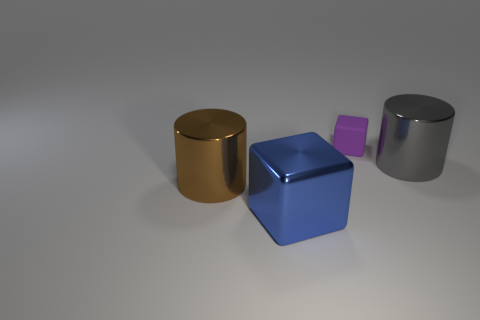Are there any other things that are made of the same material as the purple cube?
Offer a very short reply. No. There is a brown cylinder that is made of the same material as the large cube; what size is it?
Your answer should be compact. Large. There is a thing that is left of the large metal cube; what is its shape?
Provide a short and direct response. Cylinder. Are there any large things?
Provide a short and direct response. Yes. What is the shape of the metal thing behind the cylinder in front of the large metallic cylinder behind the big brown metal cylinder?
Ensure brevity in your answer.  Cylinder. How many blocks are behind the large gray thing?
Your response must be concise. 1. Is the material of the cylinder on the left side of the big gray shiny thing the same as the purple object?
Offer a very short reply. No. What number of other objects are the same shape as the small purple thing?
Your response must be concise. 1. What number of big metal objects are in front of the big cylinder to the left of the large metal cylinder behind the brown cylinder?
Make the answer very short. 1. There is a big cylinder to the left of the blue object; what color is it?
Provide a short and direct response. Brown. 